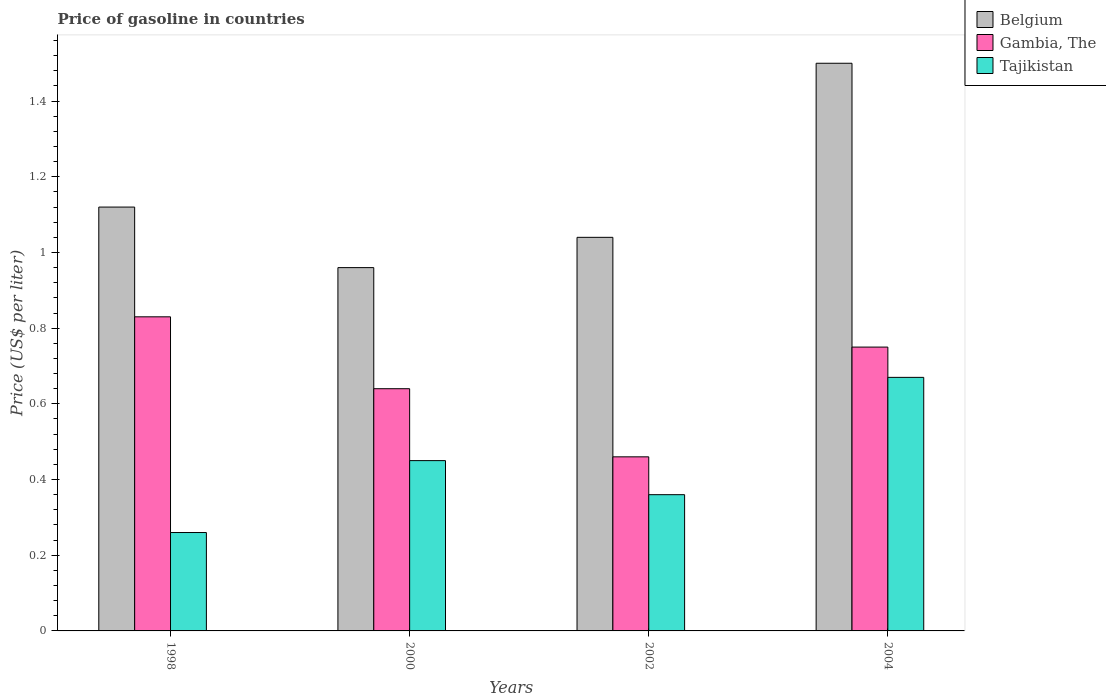How many different coloured bars are there?
Your answer should be very brief. 3. Are the number of bars on each tick of the X-axis equal?
Your answer should be compact. Yes. How many bars are there on the 4th tick from the right?
Offer a terse response. 3. What is the label of the 3rd group of bars from the left?
Give a very brief answer. 2002. What is the price of gasoline in Belgium in 1998?
Give a very brief answer. 1.12. Across all years, what is the maximum price of gasoline in Tajikistan?
Ensure brevity in your answer.  0.67. In which year was the price of gasoline in Belgium maximum?
Ensure brevity in your answer.  2004. What is the total price of gasoline in Belgium in the graph?
Offer a very short reply. 4.62. What is the difference between the price of gasoline in Gambia, The in 2002 and that in 2004?
Your answer should be compact. -0.29. What is the average price of gasoline in Gambia, The per year?
Offer a very short reply. 0.67. In the year 2004, what is the difference between the price of gasoline in Tajikistan and price of gasoline in Belgium?
Your response must be concise. -0.83. What is the ratio of the price of gasoline in Gambia, The in 1998 to that in 2004?
Your response must be concise. 1.11. Is the price of gasoline in Tajikistan in 1998 less than that in 2000?
Provide a short and direct response. Yes. Is the difference between the price of gasoline in Tajikistan in 1998 and 2004 greater than the difference between the price of gasoline in Belgium in 1998 and 2004?
Provide a short and direct response. No. What is the difference between the highest and the second highest price of gasoline in Belgium?
Give a very brief answer. 0.38. What is the difference between the highest and the lowest price of gasoline in Belgium?
Provide a short and direct response. 0.54. What does the 2nd bar from the right in 2004 represents?
Ensure brevity in your answer.  Gambia, The. Is it the case that in every year, the sum of the price of gasoline in Belgium and price of gasoline in Gambia, The is greater than the price of gasoline in Tajikistan?
Make the answer very short. Yes. How many years are there in the graph?
Offer a very short reply. 4. What is the difference between two consecutive major ticks on the Y-axis?
Your response must be concise. 0.2. Does the graph contain any zero values?
Give a very brief answer. No. Where does the legend appear in the graph?
Provide a short and direct response. Top right. What is the title of the graph?
Offer a very short reply. Price of gasoline in countries. Does "Cote d'Ivoire" appear as one of the legend labels in the graph?
Provide a succinct answer. No. What is the label or title of the Y-axis?
Offer a terse response. Price (US$ per liter). What is the Price (US$ per liter) of Belgium in 1998?
Your answer should be very brief. 1.12. What is the Price (US$ per liter) in Gambia, The in 1998?
Provide a short and direct response. 0.83. What is the Price (US$ per liter) of Tajikistan in 1998?
Offer a very short reply. 0.26. What is the Price (US$ per liter) of Belgium in 2000?
Give a very brief answer. 0.96. What is the Price (US$ per liter) in Gambia, The in 2000?
Make the answer very short. 0.64. What is the Price (US$ per liter) in Tajikistan in 2000?
Offer a very short reply. 0.45. What is the Price (US$ per liter) in Gambia, The in 2002?
Offer a very short reply. 0.46. What is the Price (US$ per liter) in Tajikistan in 2002?
Ensure brevity in your answer.  0.36. What is the Price (US$ per liter) of Belgium in 2004?
Keep it short and to the point. 1.5. What is the Price (US$ per liter) in Tajikistan in 2004?
Make the answer very short. 0.67. Across all years, what is the maximum Price (US$ per liter) of Belgium?
Provide a short and direct response. 1.5. Across all years, what is the maximum Price (US$ per liter) in Gambia, The?
Ensure brevity in your answer.  0.83. Across all years, what is the maximum Price (US$ per liter) in Tajikistan?
Offer a very short reply. 0.67. Across all years, what is the minimum Price (US$ per liter) of Belgium?
Offer a terse response. 0.96. Across all years, what is the minimum Price (US$ per liter) of Gambia, The?
Keep it short and to the point. 0.46. Across all years, what is the minimum Price (US$ per liter) of Tajikistan?
Make the answer very short. 0.26. What is the total Price (US$ per liter) in Belgium in the graph?
Offer a very short reply. 4.62. What is the total Price (US$ per liter) of Gambia, The in the graph?
Offer a terse response. 2.68. What is the total Price (US$ per liter) of Tajikistan in the graph?
Your answer should be compact. 1.74. What is the difference between the Price (US$ per liter) of Belgium in 1998 and that in 2000?
Give a very brief answer. 0.16. What is the difference between the Price (US$ per liter) of Gambia, The in 1998 and that in 2000?
Ensure brevity in your answer.  0.19. What is the difference between the Price (US$ per liter) in Tajikistan in 1998 and that in 2000?
Ensure brevity in your answer.  -0.19. What is the difference between the Price (US$ per liter) in Gambia, The in 1998 and that in 2002?
Offer a terse response. 0.37. What is the difference between the Price (US$ per liter) of Tajikistan in 1998 and that in 2002?
Your answer should be compact. -0.1. What is the difference between the Price (US$ per liter) of Belgium in 1998 and that in 2004?
Make the answer very short. -0.38. What is the difference between the Price (US$ per liter) in Gambia, The in 1998 and that in 2004?
Ensure brevity in your answer.  0.08. What is the difference between the Price (US$ per liter) in Tajikistan in 1998 and that in 2004?
Offer a very short reply. -0.41. What is the difference between the Price (US$ per liter) of Belgium in 2000 and that in 2002?
Offer a terse response. -0.08. What is the difference between the Price (US$ per liter) of Gambia, The in 2000 and that in 2002?
Offer a terse response. 0.18. What is the difference between the Price (US$ per liter) in Tajikistan in 2000 and that in 2002?
Keep it short and to the point. 0.09. What is the difference between the Price (US$ per liter) of Belgium in 2000 and that in 2004?
Give a very brief answer. -0.54. What is the difference between the Price (US$ per liter) of Gambia, The in 2000 and that in 2004?
Your response must be concise. -0.11. What is the difference between the Price (US$ per liter) in Tajikistan in 2000 and that in 2004?
Your response must be concise. -0.22. What is the difference between the Price (US$ per liter) in Belgium in 2002 and that in 2004?
Your response must be concise. -0.46. What is the difference between the Price (US$ per liter) of Gambia, The in 2002 and that in 2004?
Your response must be concise. -0.29. What is the difference between the Price (US$ per liter) in Tajikistan in 2002 and that in 2004?
Offer a very short reply. -0.31. What is the difference between the Price (US$ per liter) in Belgium in 1998 and the Price (US$ per liter) in Gambia, The in 2000?
Provide a succinct answer. 0.48. What is the difference between the Price (US$ per liter) of Belgium in 1998 and the Price (US$ per liter) of Tajikistan in 2000?
Give a very brief answer. 0.67. What is the difference between the Price (US$ per liter) in Gambia, The in 1998 and the Price (US$ per liter) in Tajikistan in 2000?
Your answer should be compact. 0.38. What is the difference between the Price (US$ per liter) of Belgium in 1998 and the Price (US$ per liter) of Gambia, The in 2002?
Make the answer very short. 0.66. What is the difference between the Price (US$ per liter) in Belgium in 1998 and the Price (US$ per liter) in Tajikistan in 2002?
Your answer should be compact. 0.76. What is the difference between the Price (US$ per liter) in Gambia, The in 1998 and the Price (US$ per liter) in Tajikistan in 2002?
Make the answer very short. 0.47. What is the difference between the Price (US$ per liter) of Belgium in 1998 and the Price (US$ per liter) of Gambia, The in 2004?
Ensure brevity in your answer.  0.37. What is the difference between the Price (US$ per liter) in Belgium in 1998 and the Price (US$ per liter) in Tajikistan in 2004?
Offer a very short reply. 0.45. What is the difference between the Price (US$ per liter) of Gambia, The in 1998 and the Price (US$ per liter) of Tajikistan in 2004?
Your response must be concise. 0.16. What is the difference between the Price (US$ per liter) of Belgium in 2000 and the Price (US$ per liter) of Gambia, The in 2002?
Provide a short and direct response. 0.5. What is the difference between the Price (US$ per liter) in Gambia, The in 2000 and the Price (US$ per liter) in Tajikistan in 2002?
Offer a very short reply. 0.28. What is the difference between the Price (US$ per liter) of Belgium in 2000 and the Price (US$ per liter) of Gambia, The in 2004?
Your answer should be compact. 0.21. What is the difference between the Price (US$ per liter) of Belgium in 2000 and the Price (US$ per liter) of Tajikistan in 2004?
Give a very brief answer. 0.29. What is the difference between the Price (US$ per liter) of Gambia, The in 2000 and the Price (US$ per liter) of Tajikistan in 2004?
Offer a very short reply. -0.03. What is the difference between the Price (US$ per liter) in Belgium in 2002 and the Price (US$ per liter) in Gambia, The in 2004?
Offer a terse response. 0.29. What is the difference between the Price (US$ per liter) of Belgium in 2002 and the Price (US$ per liter) of Tajikistan in 2004?
Provide a short and direct response. 0.37. What is the difference between the Price (US$ per liter) in Gambia, The in 2002 and the Price (US$ per liter) in Tajikistan in 2004?
Keep it short and to the point. -0.21. What is the average Price (US$ per liter) of Belgium per year?
Ensure brevity in your answer.  1.16. What is the average Price (US$ per liter) of Gambia, The per year?
Ensure brevity in your answer.  0.67. What is the average Price (US$ per liter) of Tajikistan per year?
Provide a succinct answer. 0.43. In the year 1998, what is the difference between the Price (US$ per liter) of Belgium and Price (US$ per liter) of Gambia, The?
Offer a very short reply. 0.29. In the year 1998, what is the difference between the Price (US$ per liter) of Belgium and Price (US$ per liter) of Tajikistan?
Keep it short and to the point. 0.86. In the year 1998, what is the difference between the Price (US$ per liter) of Gambia, The and Price (US$ per liter) of Tajikistan?
Your answer should be compact. 0.57. In the year 2000, what is the difference between the Price (US$ per liter) of Belgium and Price (US$ per liter) of Gambia, The?
Offer a very short reply. 0.32. In the year 2000, what is the difference between the Price (US$ per liter) of Belgium and Price (US$ per liter) of Tajikistan?
Provide a succinct answer. 0.51. In the year 2000, what is the difference between the Price (US$ per liter) of Gambia, The and Price (US$ per liter) of Tajikistan?
Offer a very short reply. 0.19. In the year 2002, what is the difference between the Price (US$ per liter) in Belgium and Price (US$ per liter) in Gambia, The?
Your answer should be very brief. 0.58. In the year 2002, what is the difference between the Price (US$ per liter) in Belgium and Price (US$ per liter) in Tajikistan?
Your answer should be compact. 0.68. In the year 2004, what is the difference between the Price (US$ per liter) in Belgium and Price (US$ per liter) in Tajikistan?
Your answer should be very brief. 0.83. In the year 2004, what is the difference between the Price (US$ per liter) of Gambia, The and Price (US$ per liter) of Tajikistan?
Offer a very short reply. 0.08. What is the ratio of the Price (US$ per liter) of Gambia, The in 1998 to that in 2000?
Keep it short and to the point. 1.3. What is the ratio of the Price (US$ per liter) in Tajikistan in 1998 to that in 2000?
Offer a very short reply. 0.58. What is the ratio of the Price (US$ per liter) in Belgium in 1998 to that in 2002?
Give a very brief answer. 1.08. What is the ratio of the Price (US$ per liter) of Gambia, The in 1998 to that in 2002?
Give a very brief answer. 1.8. What is the ratio of the Price (US$ per liter) in Tajikistan in 1998 to that in 2002?
Offer a terse response. 0.72. What is the ratio of the Price (US$ per liter) in Belgium in 1998 to that in 2004?
Your answer should be compact. 0.75. What is the ratio of the Price (US$ per liter) of Gambia, The in 1998 to that in 2004?
Give a very brief answer. 1.11. What is the ratio of the Price (US$ per liter) in Tajikistan in 1998 to that in 2004?
Your answer should be very brief. 0.39. What is the ratio of the Price (US$ per liter) of Belgium in 2000 to that in 2002?
Keep it short and to the point. 0.92. What is the ratio of the Price (US$ per liter) of Gambia, The in 2000 to that in 2002?
Your answer should be compact. 1.39. What is the ratio of the Price (US$ per liter) of Tajikistan in 2000 to that in 2002?
Your response must be concise. 1.25. What is the ratio of the Price (US$ per liter) of Belgium in 2000 to that in 2004?
Your answer should be compact. 0.64. What is the ratio of the Price (US$ per liter) in Gambia, The in 2000 to that in 2004?
Offer a terse response. 0.85. What is the ratio of the Price (US$ per liter) in Tajikistan in 2000 to that in 2004?
Offer a very short reply. 0.67. What is the ratio of the Price (US$ per liter) in Belgium in 2002 to that in 2004?
Keep it short and to the point. 0.69. What is the ratio of the Price (US$ per liter) in Gambia, The in 2002 to that in 2004?
Keep it short and to the point. 0.61. What is the ratio of the Price (US$ per liter) of Tajikistan in 2002 to that in 2004?
Your response must be concise. 0.54. What is the difference between the highest and the second highest Price (US$ per liter) of Belgium?
Your answer should be very brief. 0.38. What is the difference between the highest and the second highest Price (US$ per liter) in Gambia, The?
Ensure brevity in your answer.  0.08. What is the difference between the highest and the second highest Price (US$ per liter) of Tajikistan?
Provide a short and direct response. 0.22. What is the difference between the highest and the lowest Price (US$ per liter) in Belgium?
Offer a very short reply. 0.54. What is the difference between the highest and the lowest Price (US$ per liter) of Gambia, The?
Your answer should be very brief. 0.37. What is the difference between the highest and the lowest Price (US$ per liter) of Tajikistan?
Ensure brevity in your answer.  0.41. 